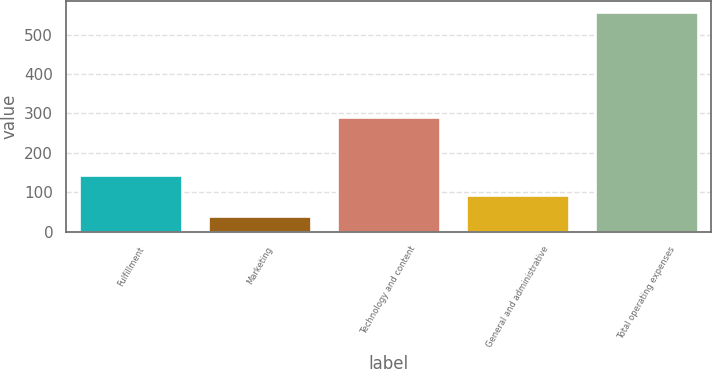<chart> <loc_0><loc_0><loc_500><loc_500><bar_chart><fcel>Fulfillment<fcel>Marketing<fcel>Technology and content<fcel>General and administrative<fcel>Total operating expenses<nl><fcel>144.8<fcel>39<fcel>292<fcel>93<fcel>557<nl></chart> 